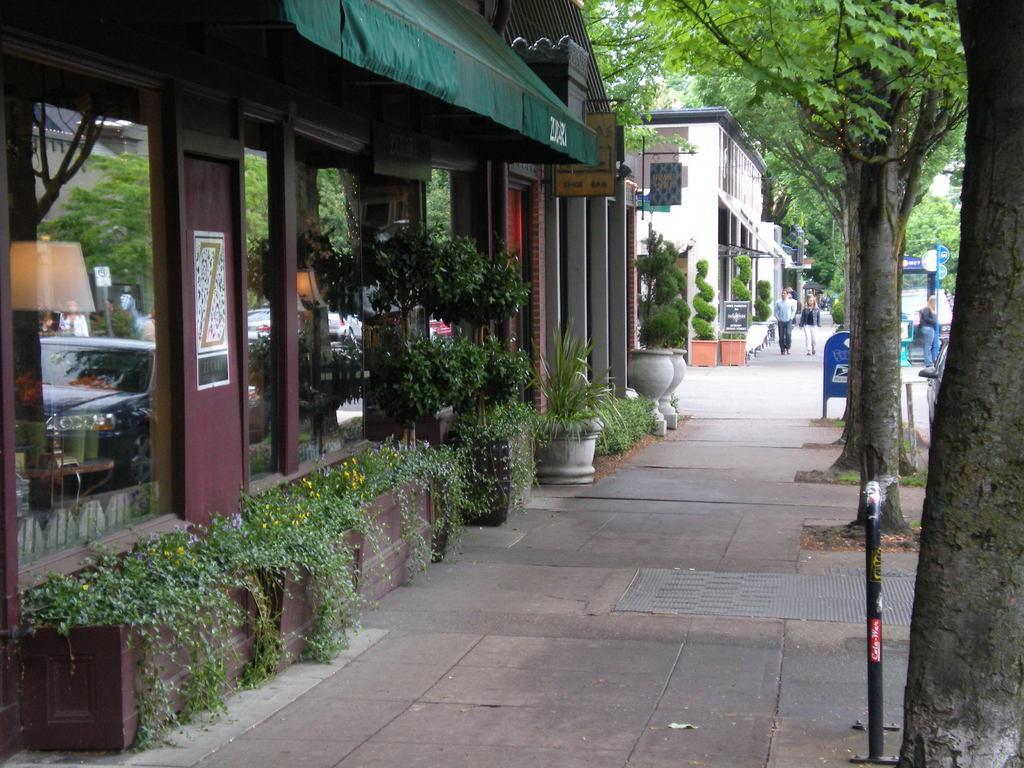Describe this image in one or two sentences. In this image I can see a path in the centre and on it I can see few people. On the right side of this image I can see number of trees, few poles, few blue colour things and one more person. On the left side I can see number of plants, few buildings, a lamp and a poster on the wall. 